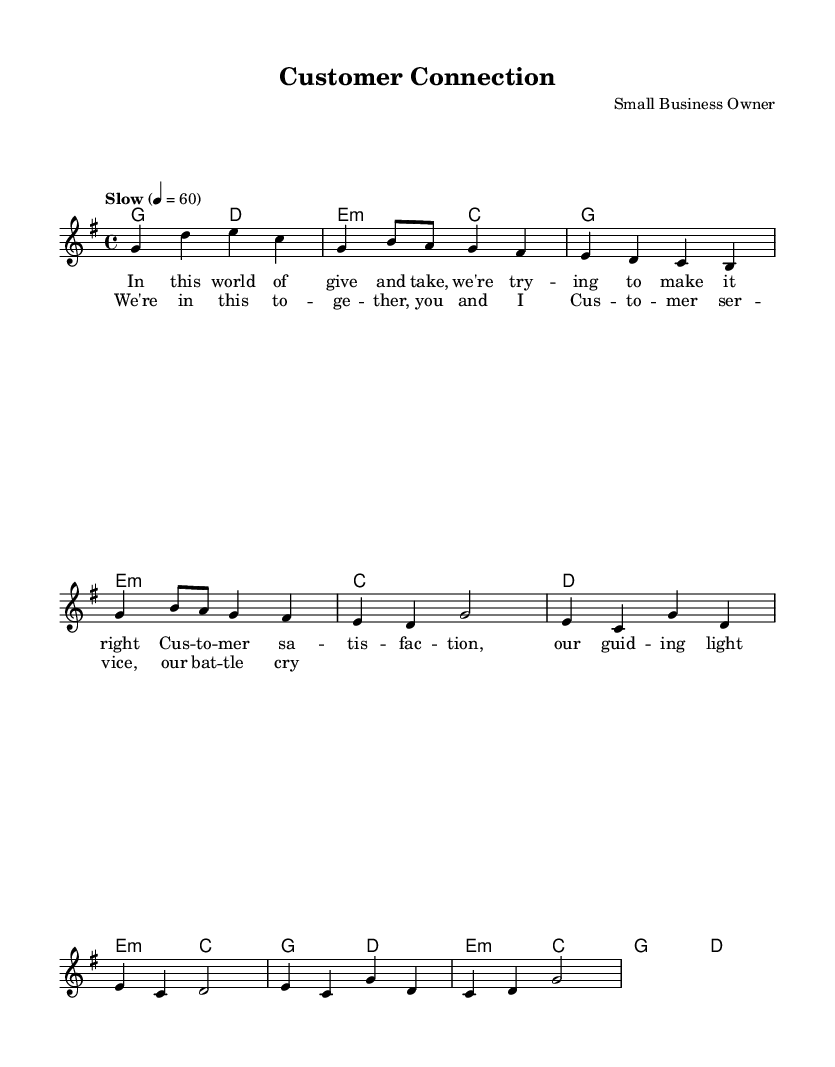What is the key signature of this music? The key signature is G major, which has one sharp (F#). This can be determined by looking at the initial key signature marking provided in the global context at the beginning of the score.
Answer: G major What is the time signature of this music? The time signature is four-four, indicated by the "4/4" marking at the beginning of the score under the global context. You can identify this formatting as it commonly denotes four beats in each measure and a quarter note receives one beat.
Answer: Four-four What is the tempo marking of this music? The tempo marking is "Slow" with a metronome marking of 60 beats per minute. This is specified in the global section of the score, indicating the intended pace for performance.
Answer: Slow What is the first line of the lyrics? The first line of the lyrics is "In this world of give and take, we're trying to make it right." This is found in the verseOne lyrics section of the score, which specifically provides the text corresponding to the melody.
Answer: In this world of give and take, we're trying to make it right How many measures are in the chorus? There are four measures in the chorus. By counting the distinct grouping of notes and assuming each musical grouping in the chorus corresponds to a measure, you can identify that there are four complete measures.
Answer: Four What is the relationship between customer service and customer satisfaction in the song? The song establishes a direct relationship by suggesting that customer satisfaction is the guiding light for the actions and decisions taken in customer service. The notion of togetherness ("We’re in this together, you and I") implies collaboration aimed at enhancing service experience. It emphasizes that the driving force behind customer interactions is the commitment to satisfy their needs.
Answer: Customer satisfaction is the guiding light 